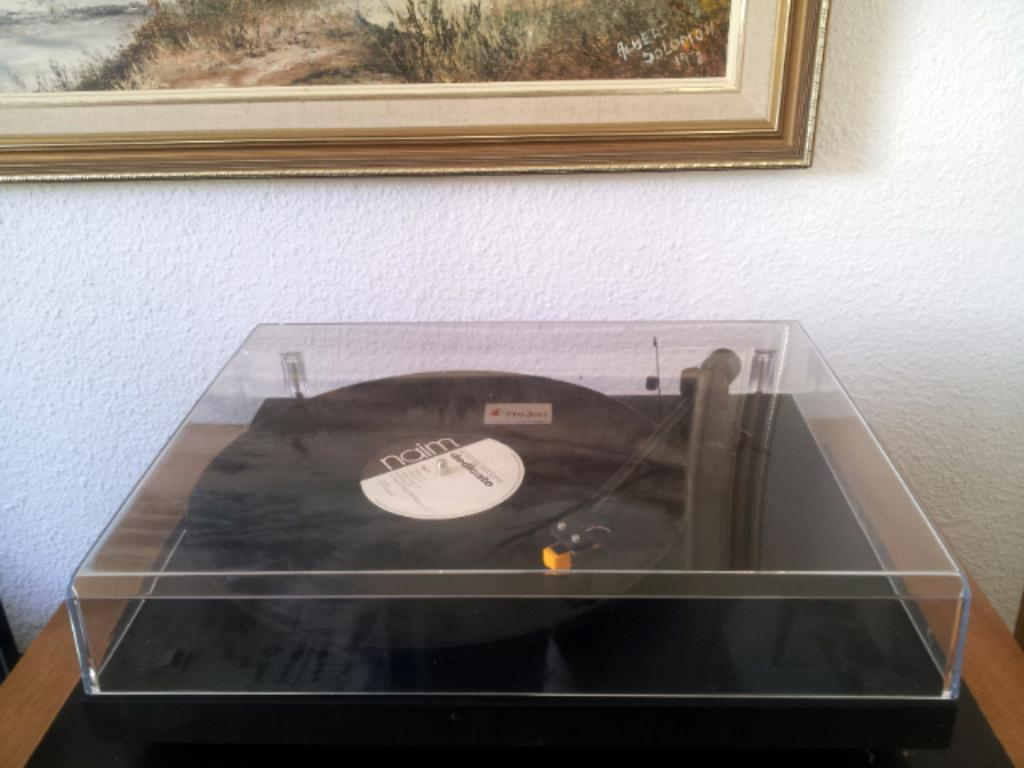What object is present in the image that plays music? There is a music player in the image. Where is the music player located? The music player is on a table. Is there anything covering the table in the image? Yes, there is a glass box covering the table. What can be seen in the background of the image? There is a frame on the wall in the background of the image. What type of linen is draped over the music player in the image? There is no linen draped over the music player in the image. How many coils are visible on the music player in the image? The image does not provide enough detail to determine the number of coils on the music player. 